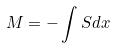<formula> <loc_0><loc_0><loc_500><loc_500>M = - \int S d x</formula> 